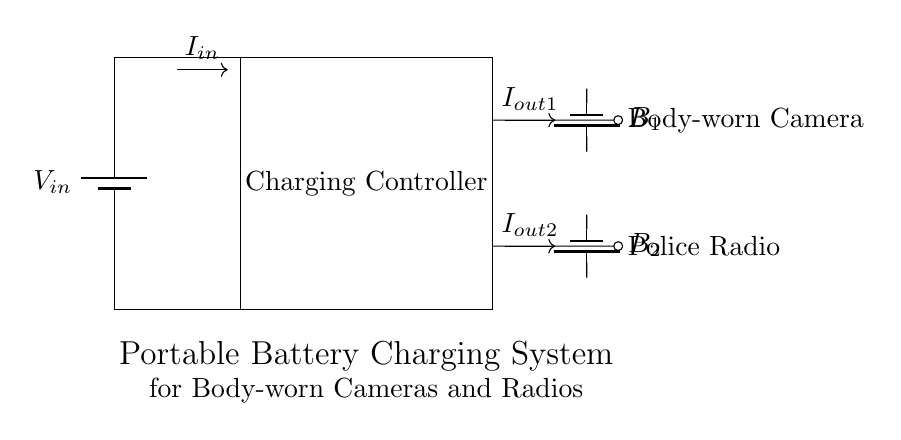What is the input voltage in the circuit? The input voltage is labeled as V_in at the top left corner of the circuit diagram, indicating the voltage supplied to the charging controller.
Answer: V_in What are the two types of devices connected to the output? The devices are labeled as Body-worn Camera and Police Radio, which are connected to the output terminals of the charging controller at the right side of the circuit.
Answer: Body-worn Camera and Police Radio How many batteries are present in the circuit? There are two batteries shown in the diagram, identified as B_1 for the Body-worn Camera and B_2 for the Police Radio, located below each respective output connection.
Answer: 2 What do the arrows in the circuit represent? The arrows denote the direction of current flow in the circuit, with I_in indicating current entering the charging controller and I_out1 and I_out2 indicating current going to each device.
Answer: Current flow What is the function of the charging controller? The charging controller is a component that regulates the power received from the input to effectively charge the connected devices' batteries while ensuring safe operation.
Answer: Regulates charging What is the relationship between V_in and the charging controller? V_in provides the necessary electrical energy to the charging controller which then manages the charging process for the devices connected to it, ensuring they receive the correct current and voltage.
Answer: Provides power What can you infer about the current outputs from the charging controller? The charging controller delivers current outputs I_out1 and I_out2 to the connected devices, indicating that it is designed to charge both devices simultaneously, highlighting its dual-output feature.
Answer: Dual-output charging 